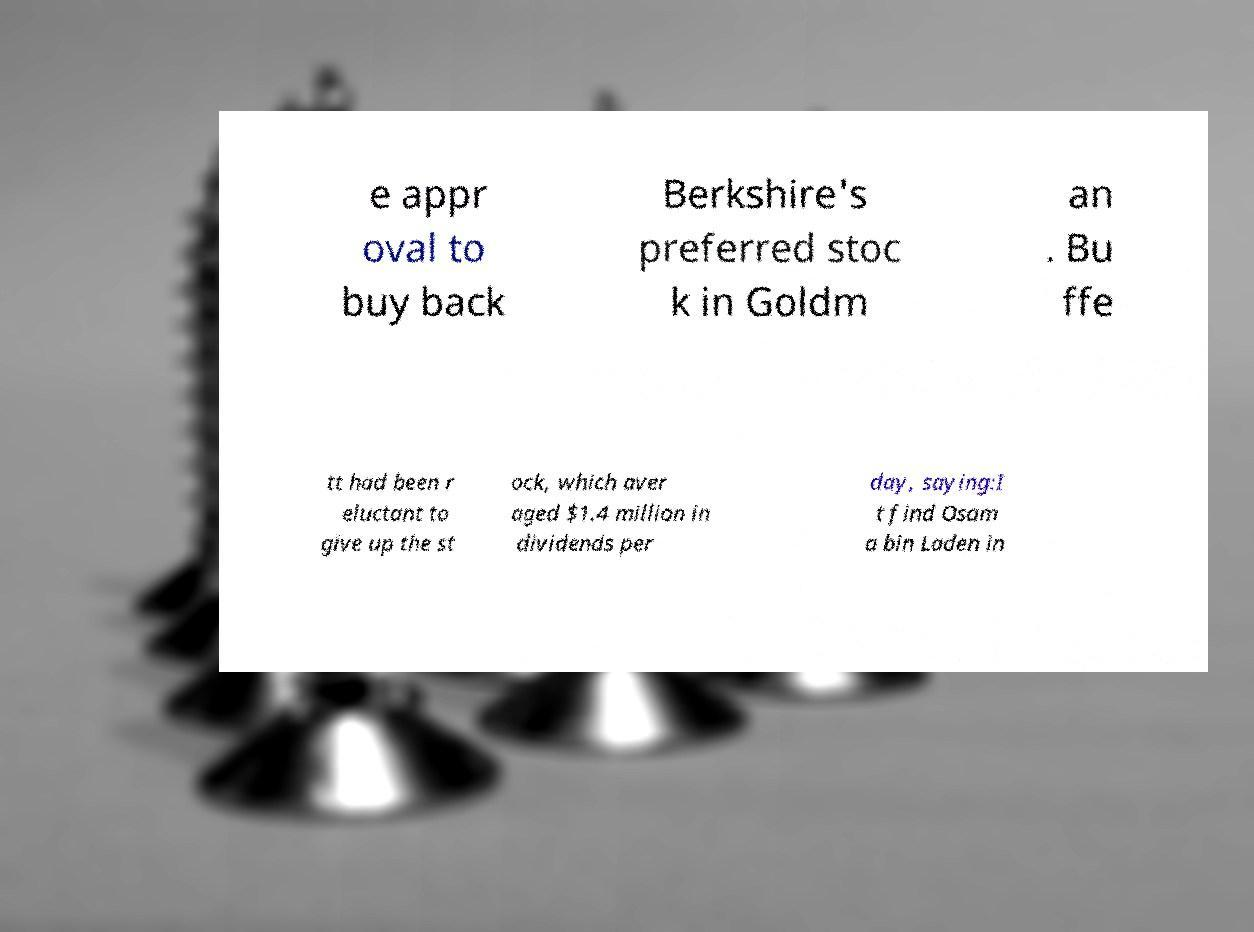Could you assist in decoding the text presented in this image and type it out clearly? e appr oval to buy back Berkshire's preferred stoc k in Goldm an . Bu ffe tt had been r eluctant to give up the st ock, which aver aged $1.4 million in dividends per day, saying:I t find Osam a bin Laden in 